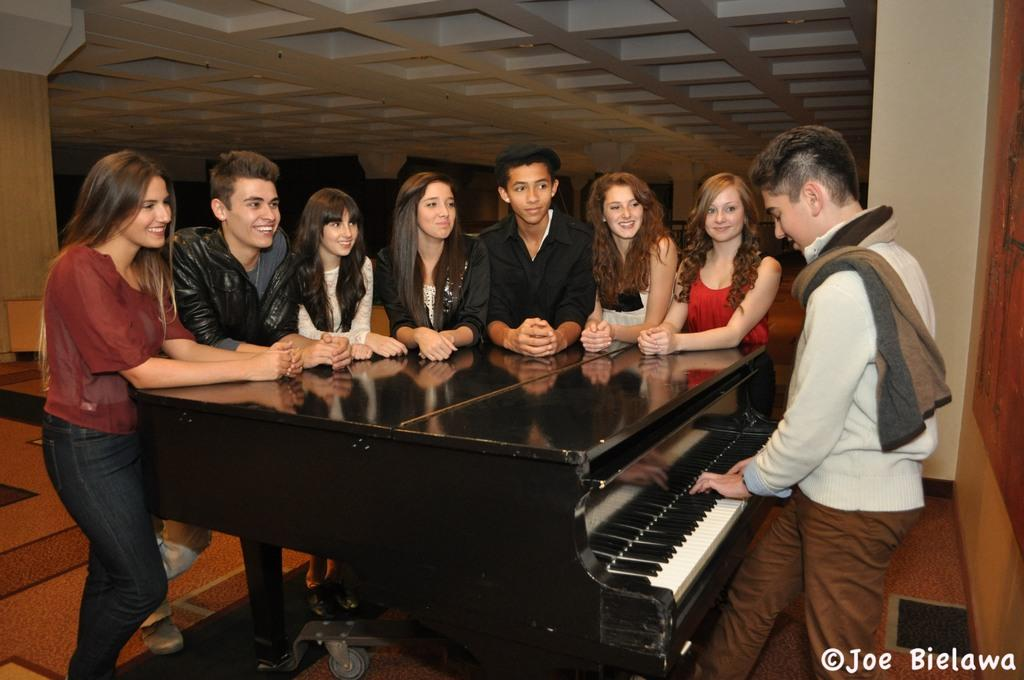What is happening in the image involving the group of people? The people in the image are standing and smiling while looking at a person playing the piano. How are the people in the group positioned? The people are standing in the image. What can be seen in the background of the image? There is a pillar and a wall in the background of the image. What type of flowers can be seen in the image? There are no flowers present in the image. Is there a cemetery visible in the image? No, there is no cemetery present in the image. 